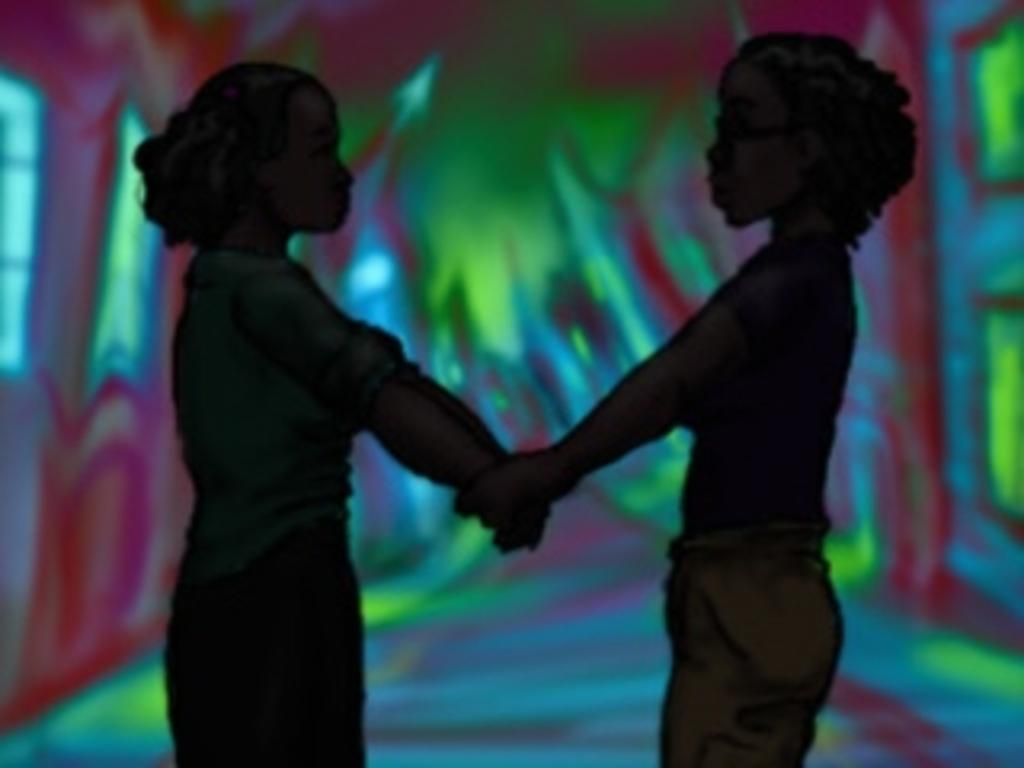What is depicted in the image? There are kids in the image. What are the kids doing in the image? The kids are holding hands. What type of artwork is the image? The image is a painting. What type of curtain is hanging in the background of the painting? There is no curtain present in the image; it is a painting of kids holding hands. What kind of plastic objects can be seen in the painting? There are no plastic objects present in the painting; it features kids holding hands. 